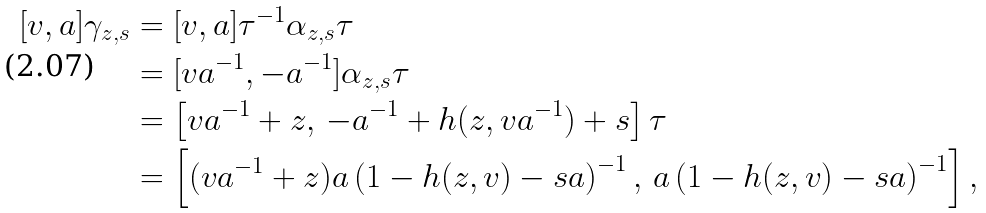Convert formula to latex. <formula><loc_0><loc_0><loc_500><loc_500>[ v , a ] \gamma _ { z , s } & = [ v , a ] \tau ^ { - 1 } \alpha _ { z , s } \tau \\ & = [ v a ^ { - 1 } , - a ^ { - 1 } ] \alpha _ { z , s } \tau \\ & = \left [ v a ^ { - 1 } + z , \, - a ^ { - 1 } + h ( z , v a ^ { - 1 } ) + s \right ] \tau \\ & = \left [ ( v a ^ { - 1 } + z ) a \left ( 1 - h ( z , v ) - s a \right ) ^ { - 1 } , \, a \left ( 1 - h ( z , v ) - s a \right ) ^ { - 1 } \right ] ,</formula> 